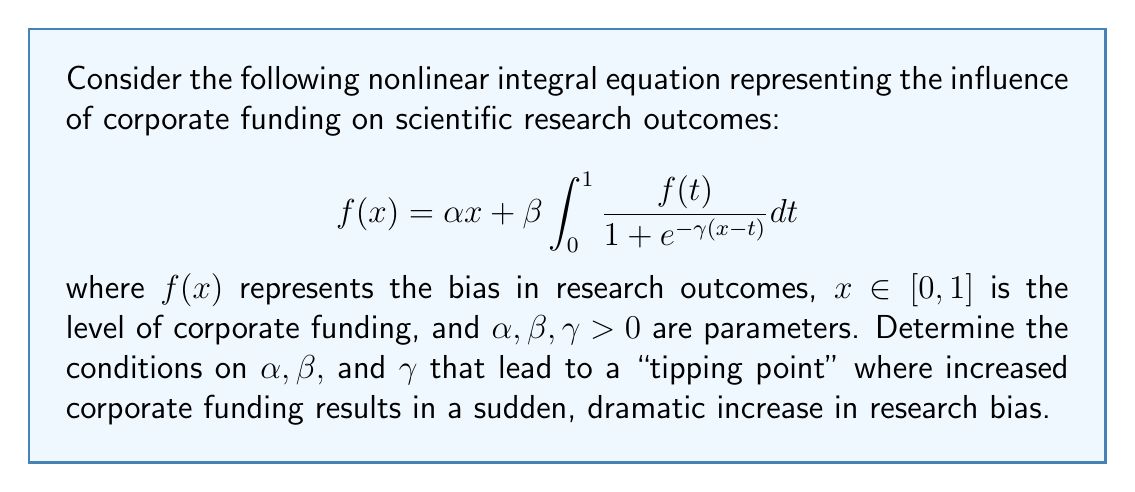Solve this math problem. To analyze the "tipping point" behavior, we need to examine the nonlinear dynamics of the system:

1) First, we differentiate both sides of the equation with respect to $x$:

   $$f'(x) = \alpha + \beta \int_0^1 \frac{f(t) \gamma e^{-\gamma(x-t)}}{(1 + e^{-\gamma(x-t)})^2} dt$$

2) At the tipping point, we expect a rapid change in $f(x)$ for a small change in $x$. This corresponds to a large value of $f'(x)$. Let's denote the maximum value of $f'(x)$ as $M$:

   $$M = \max_{x \in [0,1]} f'(x)$$

3) We can estimate an upper bound for $M$:

   $$M \leq \alpha + \beta \gamma \int_0^1 \frac{f(t)}{4} dt$$

   This is because $\frac{e^{-\gamma(x-t)}}{(1 + e^{-\gamma(x-t)})^2} \leq \frac{1}{4}$ for all $x$ and $t$.

4) Let $F = \int_0^1 f(t) dt$. Then:

   $$M \leq \alpha + \frac{\beta \gamma F}{4}$$

5) For a tipping point to occur, we need $M > 1$. This leads to the condition:

   $$\alpha + \frac{\beta \gamma F}{4} > 1$$

6) To estimate $F$, we integrate both sides of the original equation:

   $$F = \alpha \frac{1}{2} + \beta F \int_0^1 \int_0^1 \frac{1}{1 + e^{-\gamma(x-t)}} dx dt$$

7) The double integral can be approximated as $\frac{1}{2}$ for large $\gamma$. This gives:

   $$F \approx \frac{\alpha/2}{1 - \beta/2}$$

8) Substituting this back into the condition for $M > 1$:

   $$\alpha + \frac{\beta \gamma}{4} \cdot \frac{\alpha/2}{1 - \beta/2} > 1$$

9) This inequality defines the region in the $(\alpha, \beta, \gamma)$ parameter space where a tipping point is likely to occur.
Answer: $\alpha + \frac{\beta \gamma \alpha}{8(1 - \beta/2)} > 1$ 